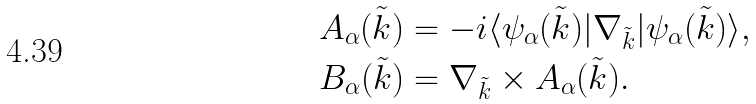<formula> <loc_0><loc_0><loc_500><loc_500>& A _ { \alpha } ( \tilde { k } ) = - i \langle \psi _ { \alpha } ( \tilde { k } ) | \nabla _ { \tilde { k } } | \psi _ { \alpha } ( \tilde { k } ) \rangle , \\ & B _ { \alpha } ( \tilde { k } ) = \nabla _ { \tilde { k } } \times A _ { \alpha } ( \tilde { k } ) .</formula> 